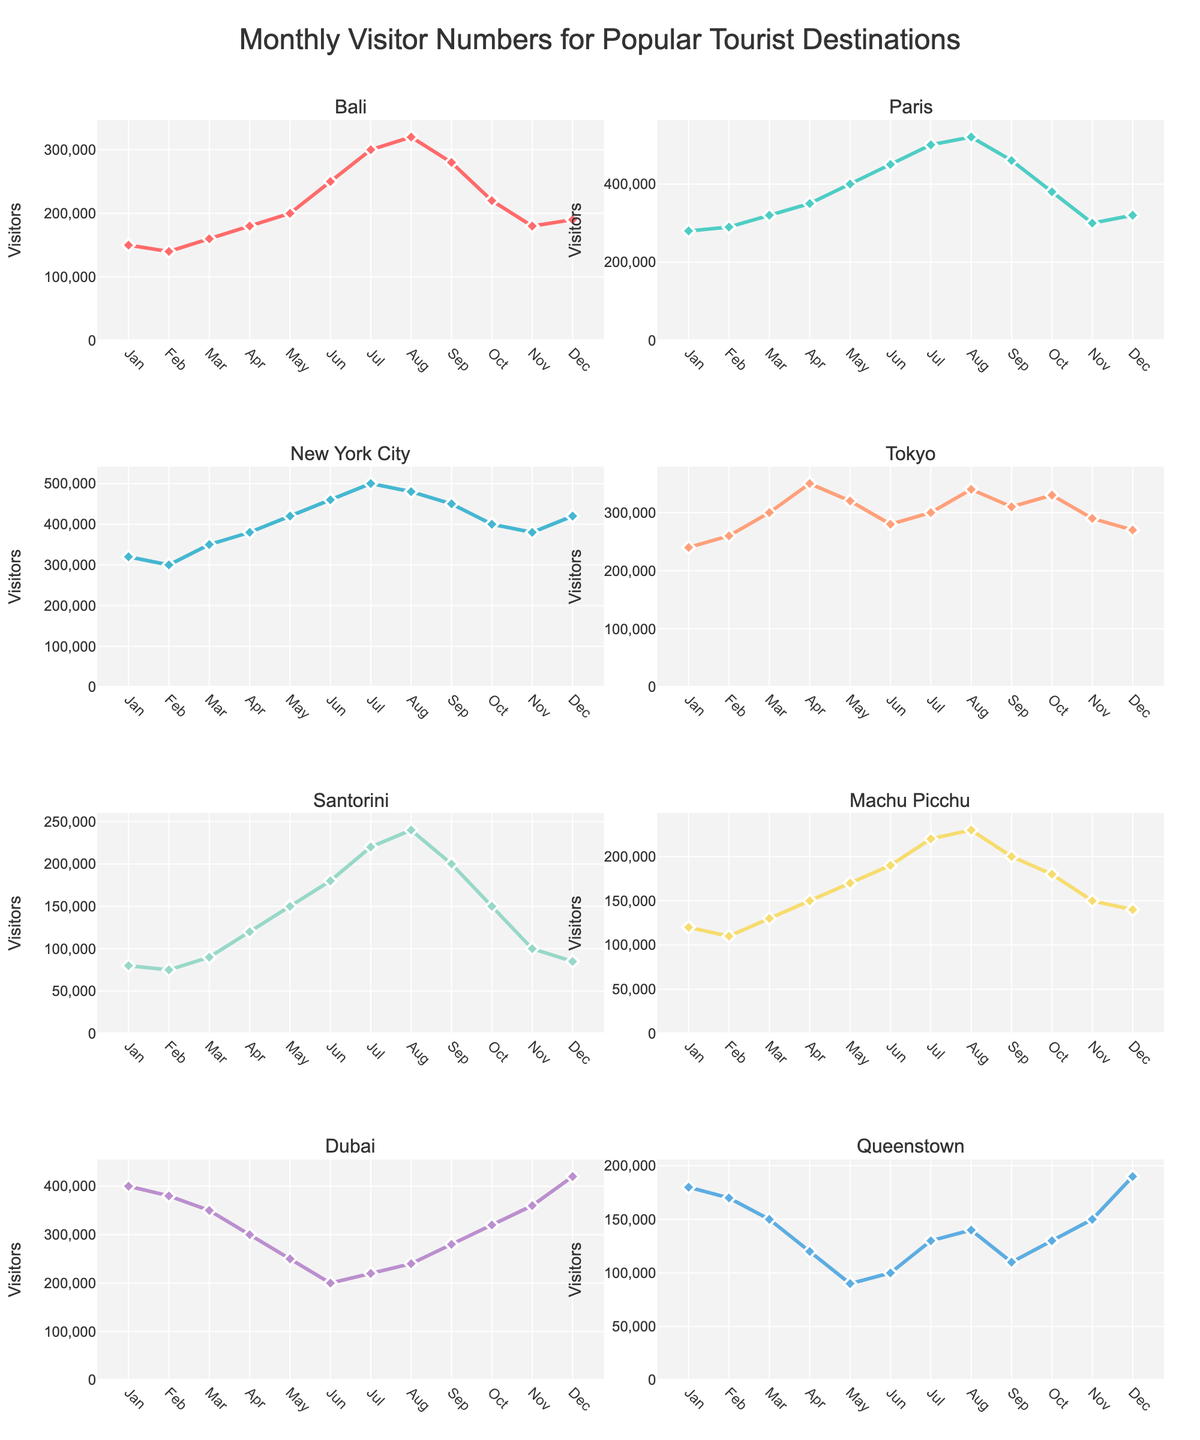What's the title of the figure? The title of the figure is displayed at the top and reads "Growth in Autograph Items Sold on Online Marketplaces (2013-2023)"
Answer: Growth in Autograph Items Sold on Online Marketplaces (2013-2023) Which marketplace had the most significant increase in the number of autograph items sold between 2013 and 2023? Compare the number of items sold in 2013 and 2023 across eBay, Amazon, Etsy, and PropStore. eBay had 10,000 in 2013 and 55,000 in 2023, showing the largest increase of 45,000 items.
Answer: eBay How many unique years are represented in each subplot? Looking at the x-axis across all subplots, the years displayed are consistently 2013, 2015, 2017, 2019, 2021, and 2023.
Answer: 6 Which marketplace had the least number of autograph items sold in 2013? Compare the values for each platform in 2013. PropStore had the least with 1,000 items sold.
Answer: PropStore Identify the year when Amazon surpassed Etsy in the number of autograph items sold. Compare the numbers for Amazon and Etsy across the years. In 2015, Amazon had 8,000 items sold while Etsy had 4,000, which is the year Amazon surpassed Etsy.
Answer: 2015 Calculate the average number of autograph items sold on Etsy between 2013 and 2023. Sum the values for Etsy from each year (2000 + 4000 + 7000 + 12000 + 18000 + 25000 = 68000) and divide by the number of years (6).
Answer: (2000 + 4000 + 7000 + 12000 + 18000 + 25000)/6 = 11333.3 Which marketplace exhibited the highest growth rate between 2013 and 2023? Calculate the growth rate for each platform. eBay's growth: (55000 - 10000) / 10000 = 4.5, Amazon's growth: (35000 - 5000) / 5000 = 6, Etsy's growth: (25000 - 2000) / 2000 = 11.5, PropStore's growth: (22000 - 1000) / 1000 = 21. PropStore exhibited the highest growth rate of 21 times.
Answer: PropStore By how much did the number of autograph items sold on eBay increase from 2019 to 2023? The number of items sold on eBay increased from 30,000 in 2019 to 55,000 in 2023. The increase is 55,000 - 30,000 = 25,000.
Answer: 25,000 Which marketplaces had a consistent positive trend over all the years? Analyze the lines in each subplot; they all show an increasing trend across all years.
Answer: eBay, Amazon, Etsy, PropStore 